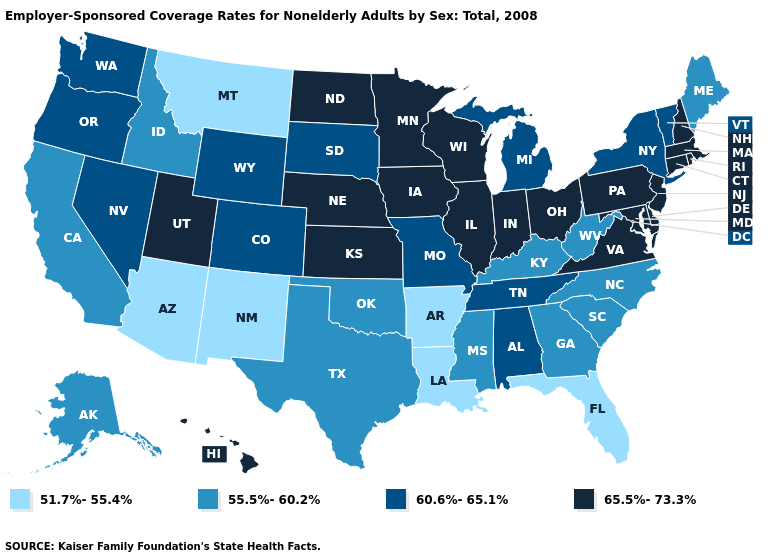Which states have the lowest value in the USA?
Keep it brief. Arizona, Arkansas, Florida, Louisiana, Montana, New Mexico. Among the states that border Connecticut , which have the lowest value?
Short answer required. New York. Name the states that have a value in the range 60.6%-65.1%?
Short answer required. Alabama, Colorado, Michigan, Missouri, Nevada, New York, Oregon, South Dakota, Tennessee, Vermont, Washington, Wyoming. Name the states that have a value in the range 51.7%-55.4%?
Answer briefly. Arizona, Arkansas, Florida, Louisiana, Montana, New Mexico. What is the lowest value in states that border South Dakota?
Answer briefly. 51.7%-55.4%. Name the states that have a value in the range 55.5%-60.2%?
Answer briefly. Alaska, California, Georgia, Idaho, Kentucky, Maine, Mississippi, North Carolina, Oklahoma, South Carolina, Texas, West Virginia. What is the value of Alabama?
Be succinct. 60.6%-65.1%. Is the legend a continuous bar?
Give a very brief answer. No. Is the legend a continuous bar?
Quick response, please. No. Name the states that have a value in the range 60.6%-65.1%?
Write a very short answer. Alabama, Colorado, Michigan, Missouri, Nevada, New York, Oregon, South Dakota, Tennessee, Vermont, Washington, Wyoming. Which states have the lowest value in the MidWest?
Short answer required. Michigan, Missouri, South Dakota. Does the map have missing data?
Give a very brief answer. No. What is the value of Wyoming?
Concise answer only. 60.6%-65.1%. What is the value of Colorado?
Concise answer only. 60.6%-65.1%. Which states have the lowest value in the South?
Be succinct. Arkansas, Florida, Louisiana. 